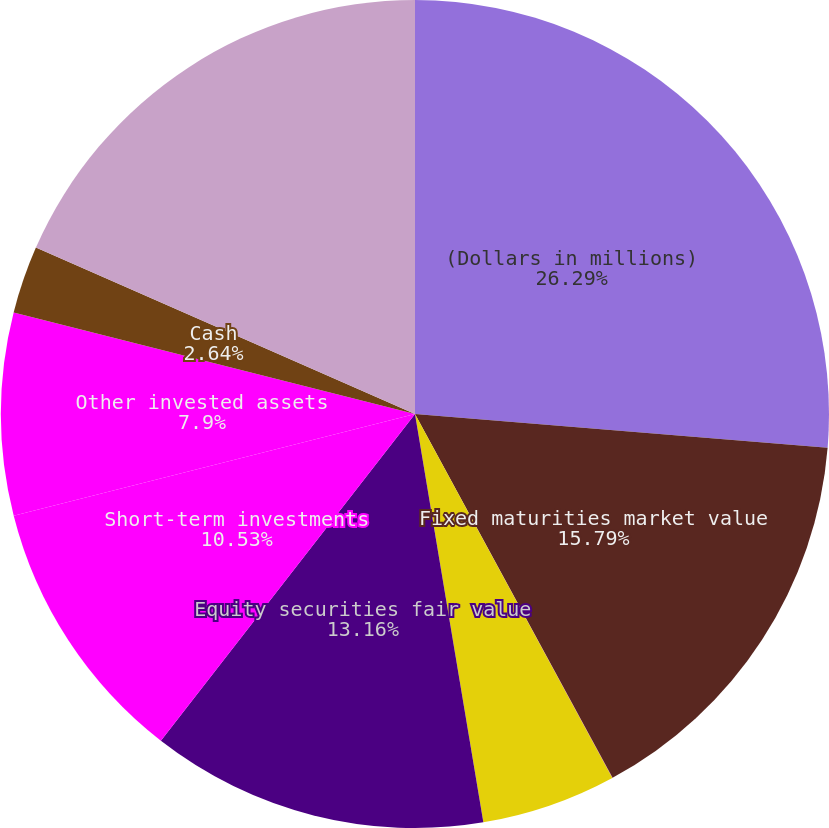<chart> <loc_0><loc_0><loc_500><loc_500><pie_chart><fcel>(Dollars in millions)<fcel>Fixed maturities market value<fcel>Fixed maturities fair value<fcel>Equity securities market value<fcel>Equity securities fair value<fcel>Short-term investments<fcel>Other invested assets<fcel>Cash<fcel>Total investments and cash<nl><fcel>26.3%<fcel>15.79%<fcel>0.01%<fcel>5.27%<fcel>13.16%<fcel>10.53%<fcel>7.9%<fcel>2.64%<fcel>18.42%<nl></chart> 